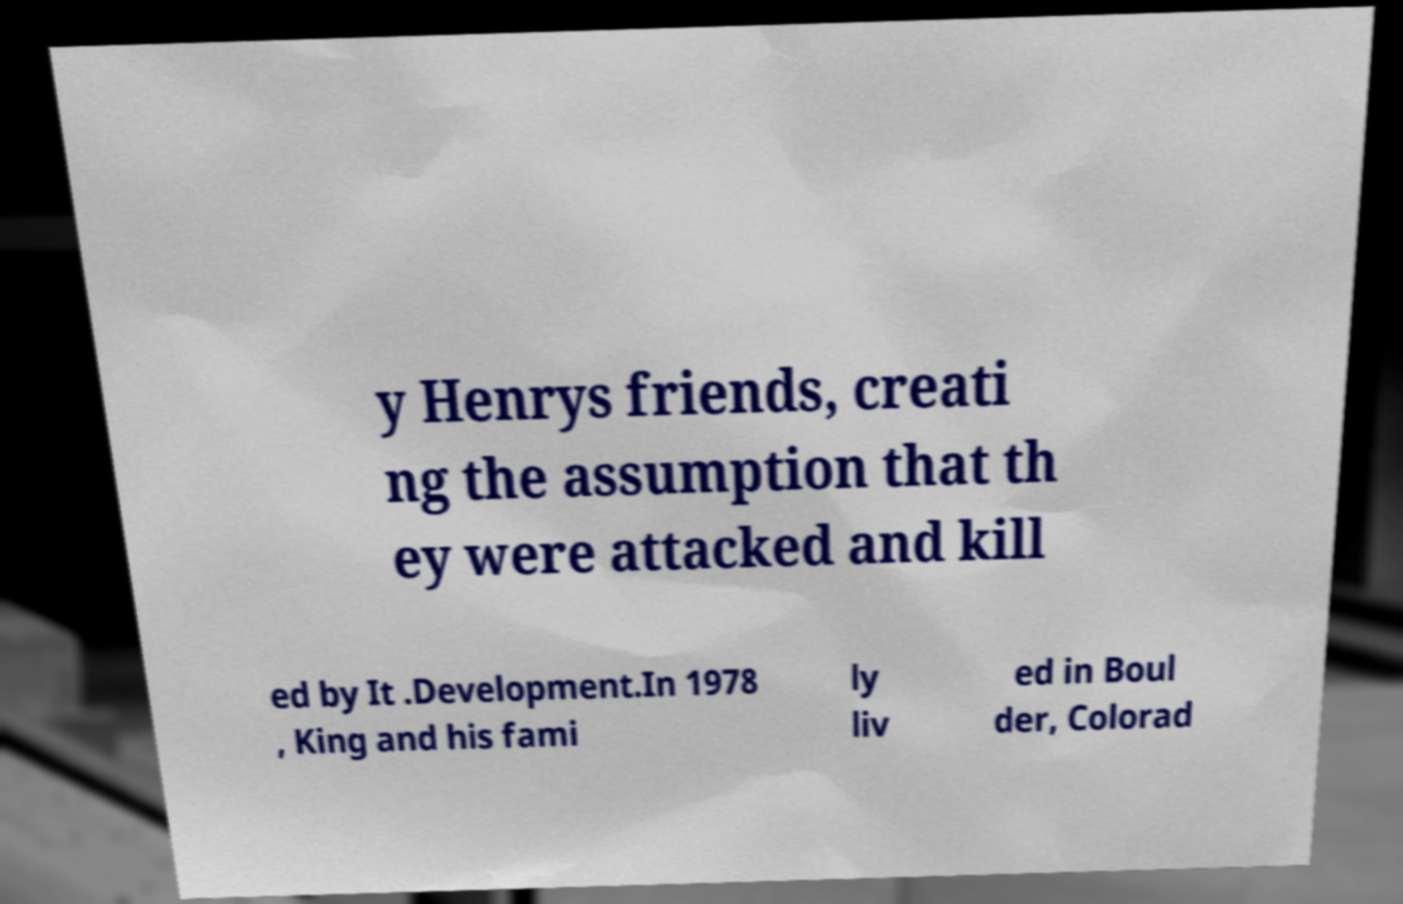Can you read and provide the text displayed in the image?This photo seems to have some interesting text. Can you extract and type it out for me? y Henrys friends, creati ng the assumption that th ey were attacked and kill ed by It .Development.In 1978 , King and his fami ly liv ed in Boul der, Colorad 